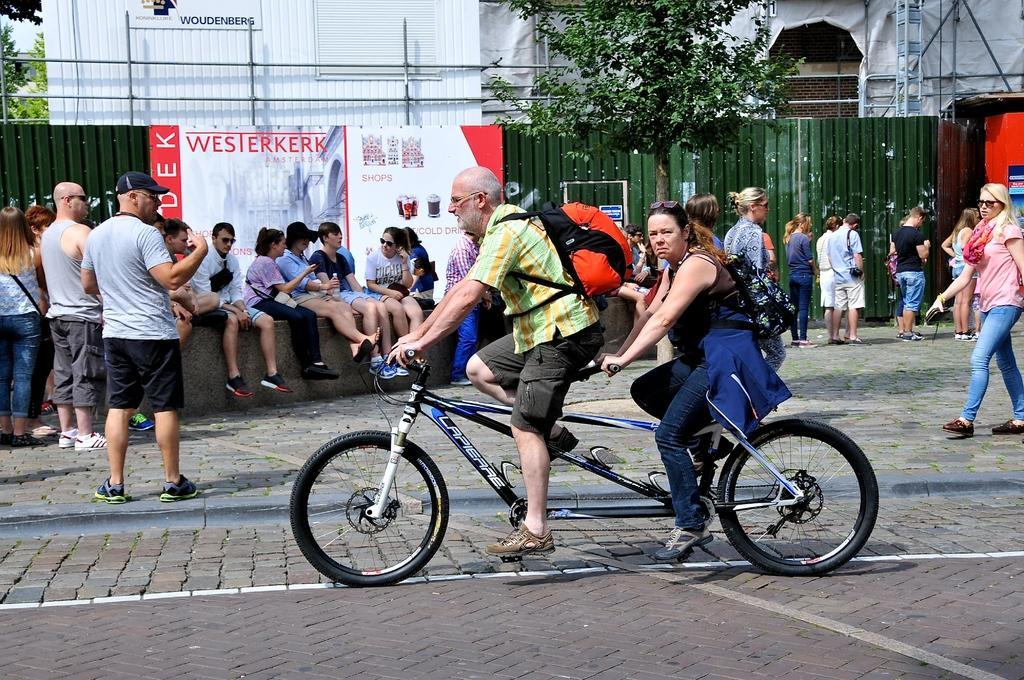In one or two sentences, can you explain what this image depicts? This image is clicked outside. There is a building on the top and trees on the top. There are so many people in this image, two of them riding bicycle and so many people they sat and people on left side and right side they are standing. 